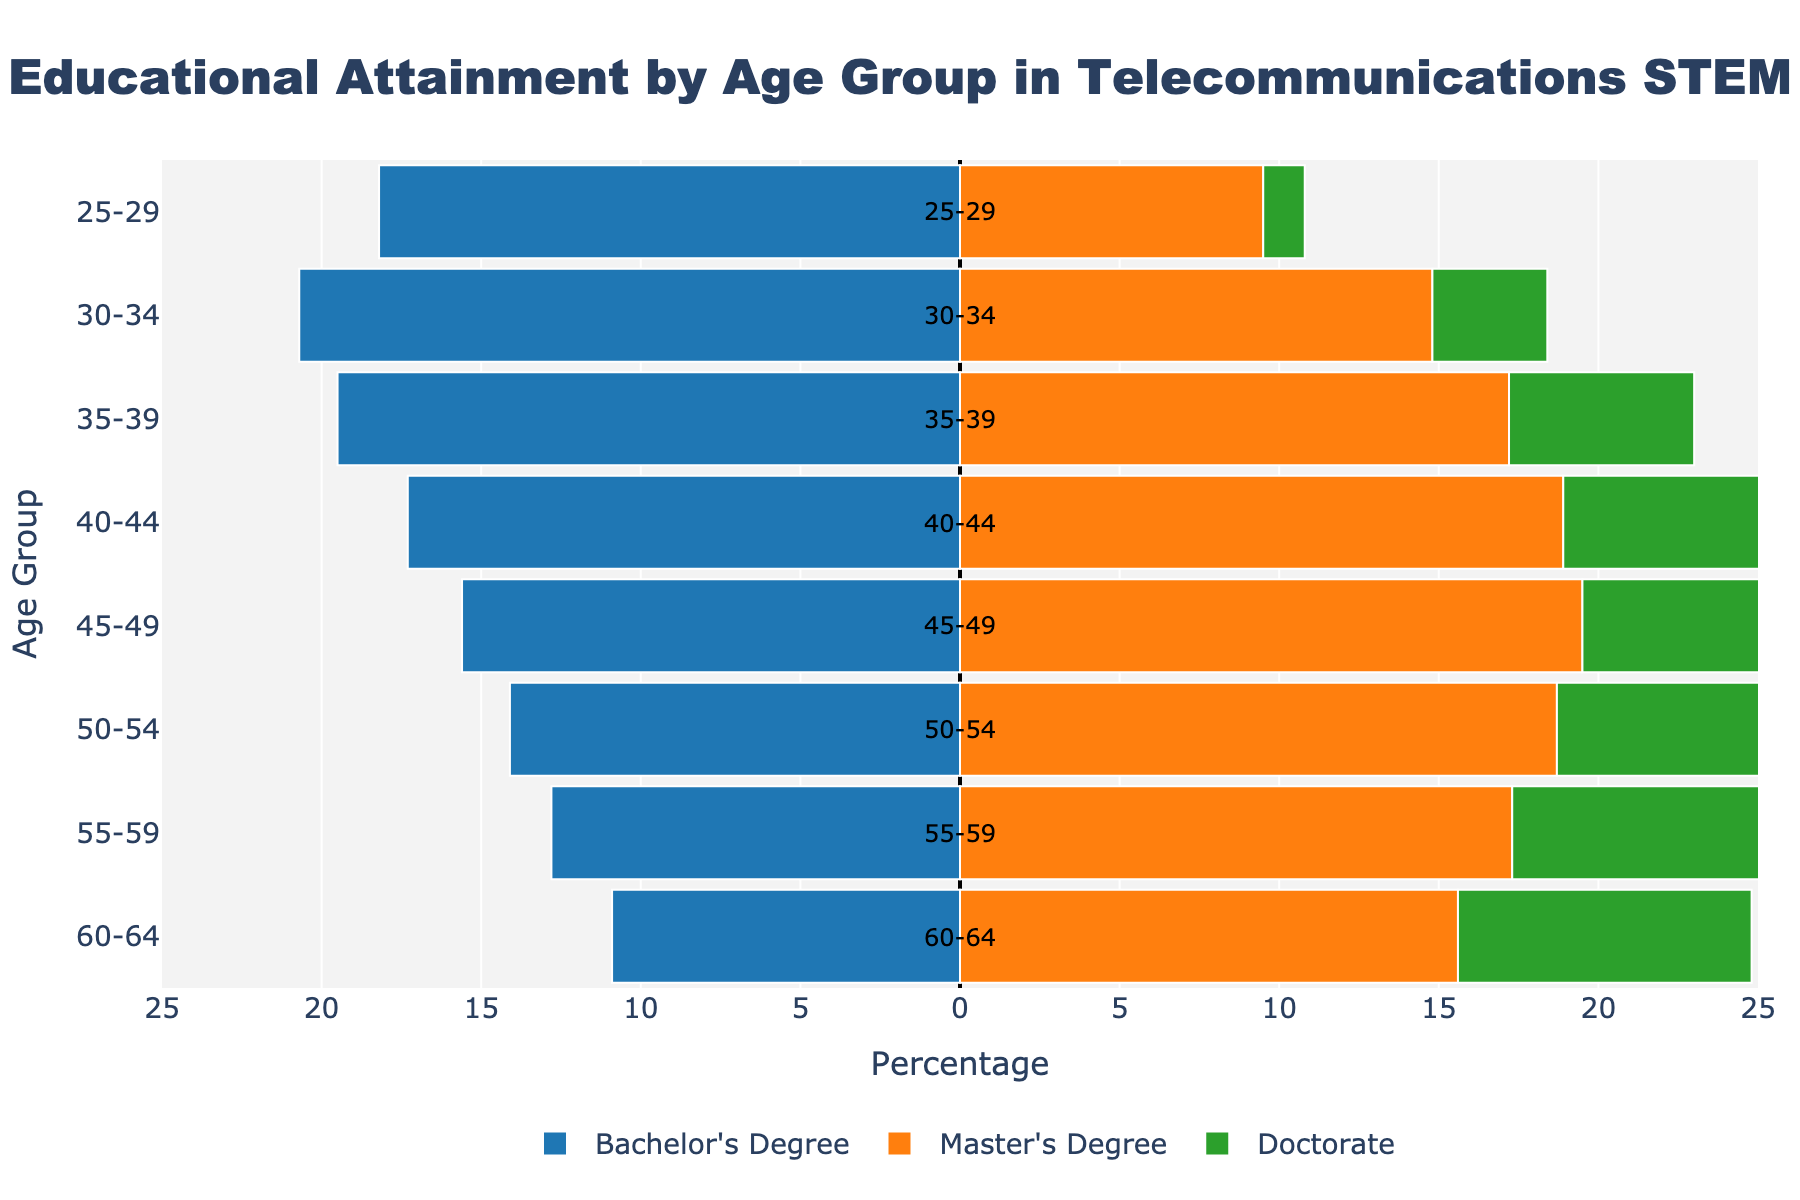What's the title of the figure? The title of the figure is displayed at the top center and reads "Educational Attainment by Age Group in Telecommunications STEM".
Answer: Educational Attainment by Age Group in Telecommunications STEM What's the percentage of Bachelor's Degree holders in the 30-34 age group? The bar for Bachelor's Degree holders in the 30-34 age group extends to -20.7, indicating 20.7%.
Answer: 20.7% Which age group has the highest percentage of Doctorate holders? Among all age groups, the 55-59 age group has the highest Doctorate percentage bar extending to 9.5%.
Answer: 55-59 How does the percentage of Master's Degree holders change from the 25-29 age group to the 45-49 age group? From the 25-29 age group (9.5%), the percentage gradually increases, reaching 19.5% in the 45-49 age group.
Answer: It increases Which age groups have a higher percentage of Master's Degree holders than Bachelor's Degree holders? Reviewing the bars for all age groups, 40-44, 45-49, 50-54, and 55-59 have higher percentages of Master's Degree holders compared to Bachelor's Degree holders.
Answer: 40-44, 45-49, 50-54, 55-59 What is the total percentage of Master's Degree holders in the 35-39 and 40-44 age groups combined? The percentage for Master's Degree holders in the 35-39 age group is 17.2%, and in the 40-44 age group, it is 18.9%. Summing these gives 17.2% + 18.9% = 36.1%.
Answer: 36.1% Comparing the 25-29 and 55-59 age groups, which one has a higher percentage of Bachelor’s Degree holders, and by how much? The 25-29 age group has 18.2%, while the 55-59 age group has 12.8%. The difference is 18.2% - 12.8% = 5.4%.
Answer: 25-29, by 5.4% What is the average percentage of Doctorate holders across all age groups? The percentages for the Doctorate across age groups are 1.3, 3.6, 5.8, 7.2, 8.4, 9.1, 9.5, and 9.2. Summing these and dividing by 8 gives (1.3 + 3.6 + 5.8 + 7.2 + 8.4 + 9.1 + 9.5 + 9.2)/8 = 7.0125%.
Answer: 7.01% What trend can be observed for Bachelor's Degree holders as the age group increases? The percentage of Bachelor's Degree holders generally decreases as the age group increases.
Answer: It decreases Which degree has the smallest percentage in the 30-34 age group? The bar representing the Doctorate percentage in the 30-34 age group is the smallest, at 3.6%.
Answer: Doctorate 